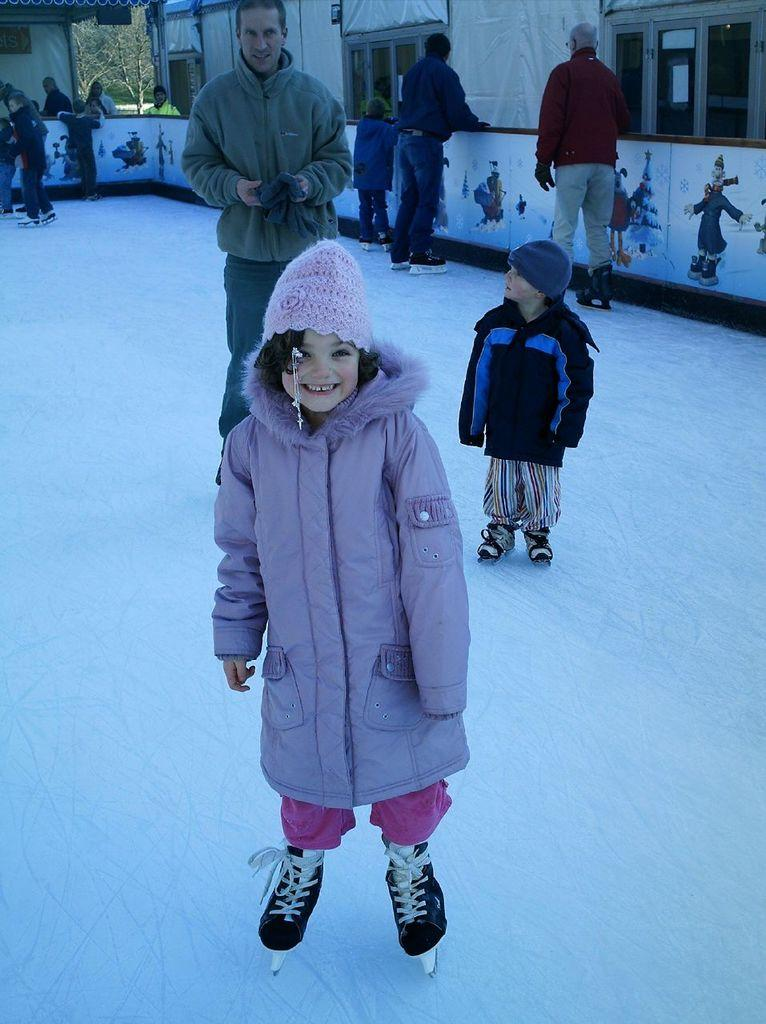What is the main subject in the foreground of the image? There is a girl standing on the snow in the foreground of the image. What can be seen in the background of the image? There are people, windows, a boundary, a house, and trees in the background of the image. Can you describe the setting of the image? The girl is standing on snow in the foreground, and there is a house and trees in the background, suggesting a winter scene. What type of chain is being developed in the image? There is no chain or development process present in the image. What is the limit of the trees in the image? The image does not indicate any specific limit for the trees; they are simply visible in the background. 